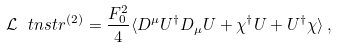Convert formula to latex. <formula><loc_0><loc_0><loc_500><loc_500>\mathcal { L } _ { \ } t n { s t r } ^ { ( 2 ) } = \frac { F _ { 0 } ^ { 2 } } { 4 } \langle D ^ { \mu } U ^ { \dagger } D _ { \mu } U + \chi ^ { \dagger } U + U ^ { \dagger } \chi \rangle \, ,</formula> 